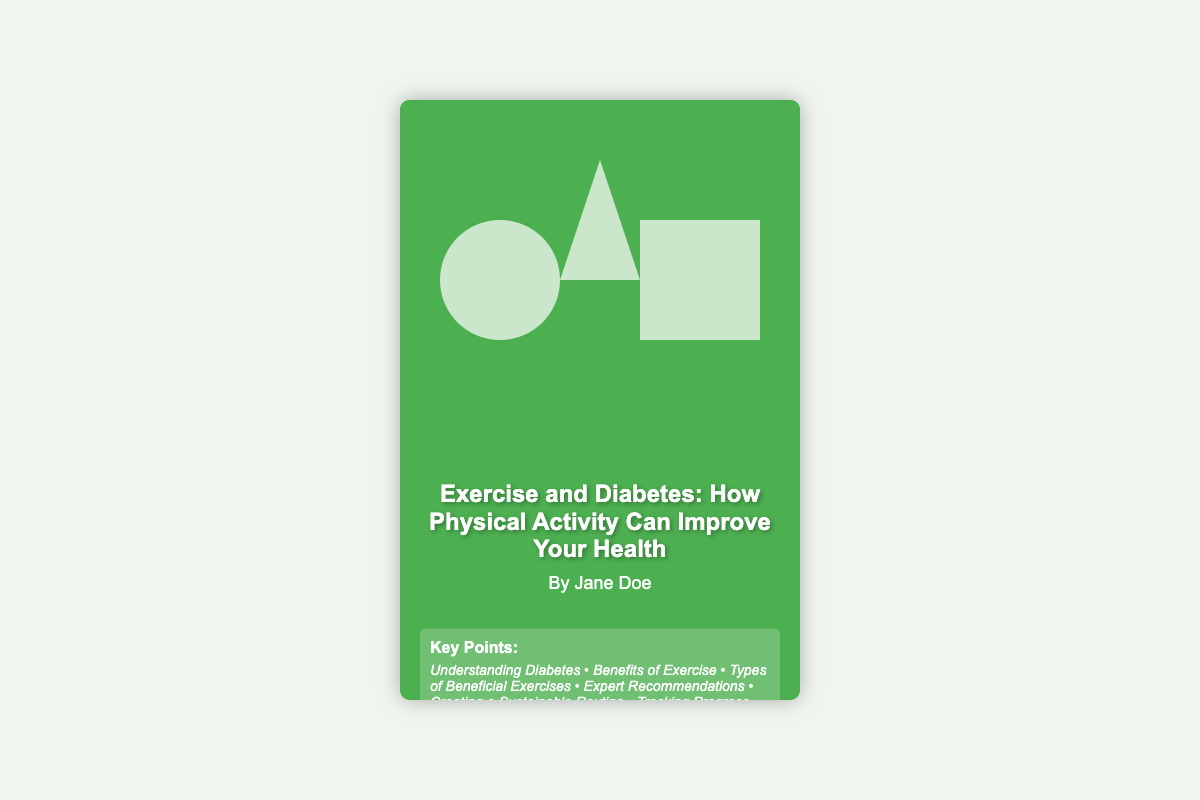What is the title of the book? The title is prominently displayed on the cover of the document.
Answer: Exercise and Diabetes: How Physical Activity Can Improve Your Health Who is the author of the book? The author's name is listed below the title on the cover.
Answer: Jane Doe What color is the background of the book cover? The background color is specified in the document's CSS styling for the book cover.
Answer: Green What are two types of exercises mentioned? The key points section alludes to beneficial exercises, which can include various physical activities.
Answer: Jogging, yoga How many key points are listed on the cover? The key points section summarizes the main topics of the book into a single line.
Answer: Six What theme do the silhouettes represent on the cover? The silhouettes illustrate engagement in physical activities pertinent to the book's focus.
Answer: Physical activity In what format is the book cover displayed? The format reflects the properties and stylings set out in the CSS and HTML of the document.
Answer: Visual book cover What is the primary focus of the book? The title provides insight into the main topic of the book, emphasizing the impact of exercise.
Answer: Physical activity improvement 